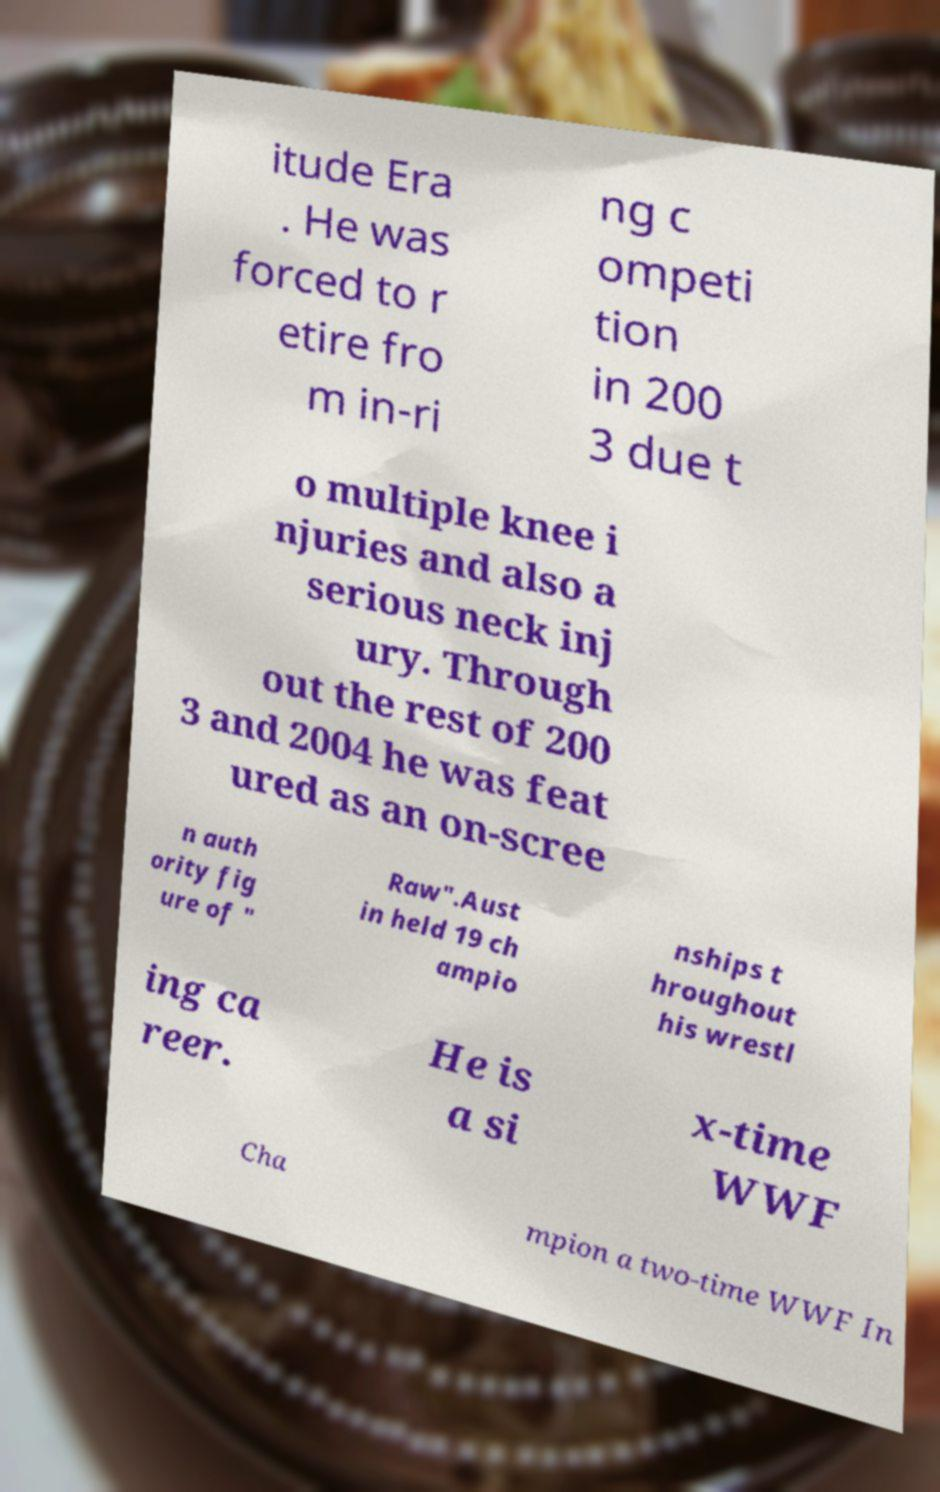What messages or text are displayed in this image? I need them in a readable, typed format. itude Era . He was forced to r etire fro m in-ri ng c ompeti tion in 200 3 due t o multiple knee i njuries and also a serious neck inj ury. Through out the rest of 200 3 and 2004 he was feat ured as an on-scree n auth ority fig ure of " Raw".Aust in held 19 ch ampio nships t hroughout his wrestl ing ca reer. He is a si x-time WWF Cha mpion a two-time WWF In 